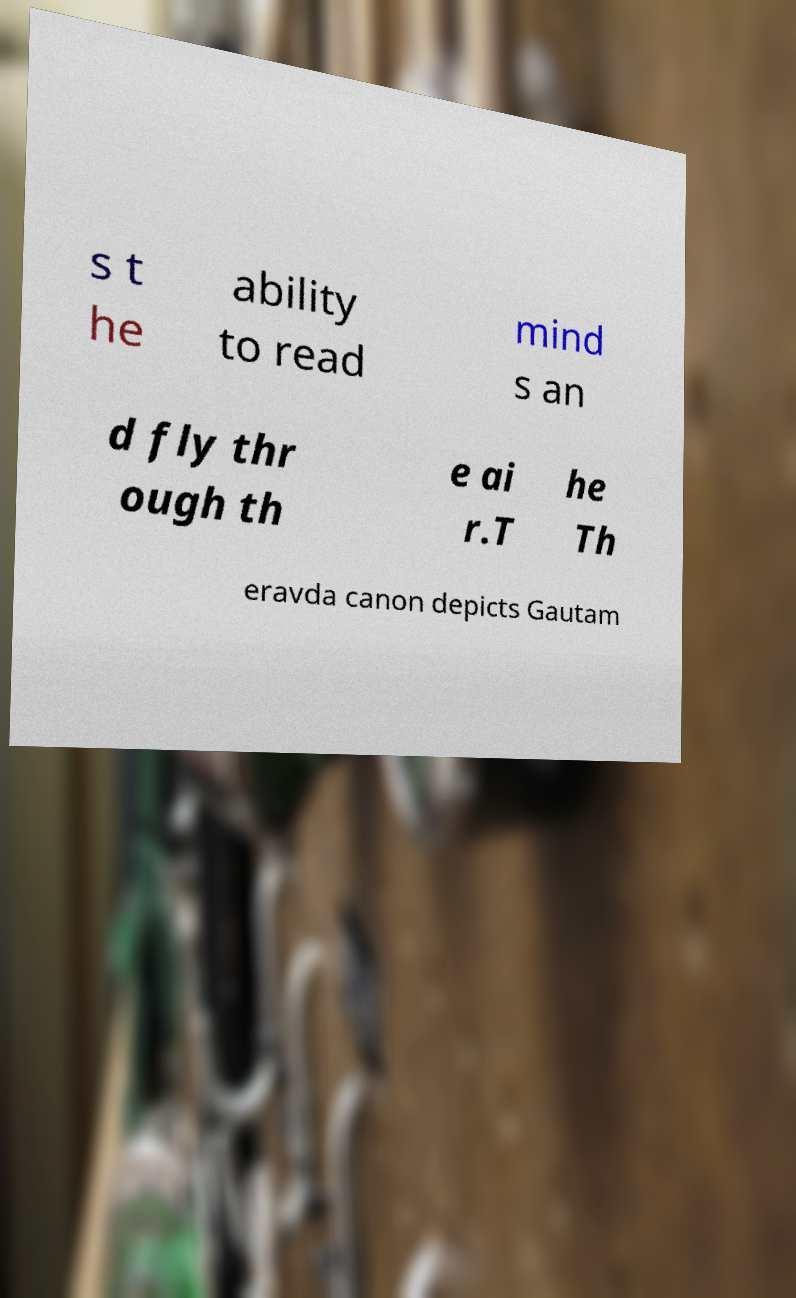Could you assist in decoding the text presented in this image and type it out clearly? s t he ability to read mind s an d fly thr ough th e ai r.T he Th eravda canon depicts Gautam 